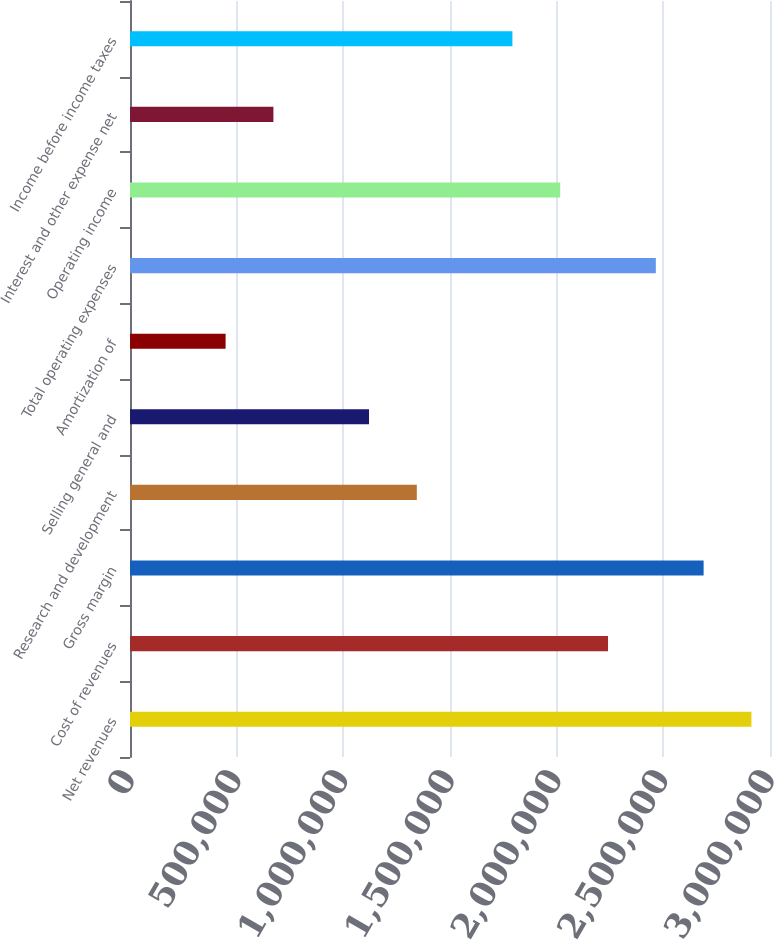Convert chart. <chart><loc_0><loc_0><loc_500><loc_500><bar_chart><fcel>Net revenues<fcel>Cost of revenues<fcel>Gross margin<fcel>Research and development<fcel>Selling general and<fcel>Amortization of<fcel>Total operating expenses<fcel>Operating income<fcel>Interest and other expense net<fcel>Income before income taxes<nl><fcel>2.91296e+06<fcel>2.24074e+06<fcel>2.68888e+06<fcel>1.34444e+06<fcel>1.12037e+06<fcel>448149<fcel>2.46481e+06<fcel>2.01666e+06<fcel>672222<fcel>1.79259e+06<nl></chart> 